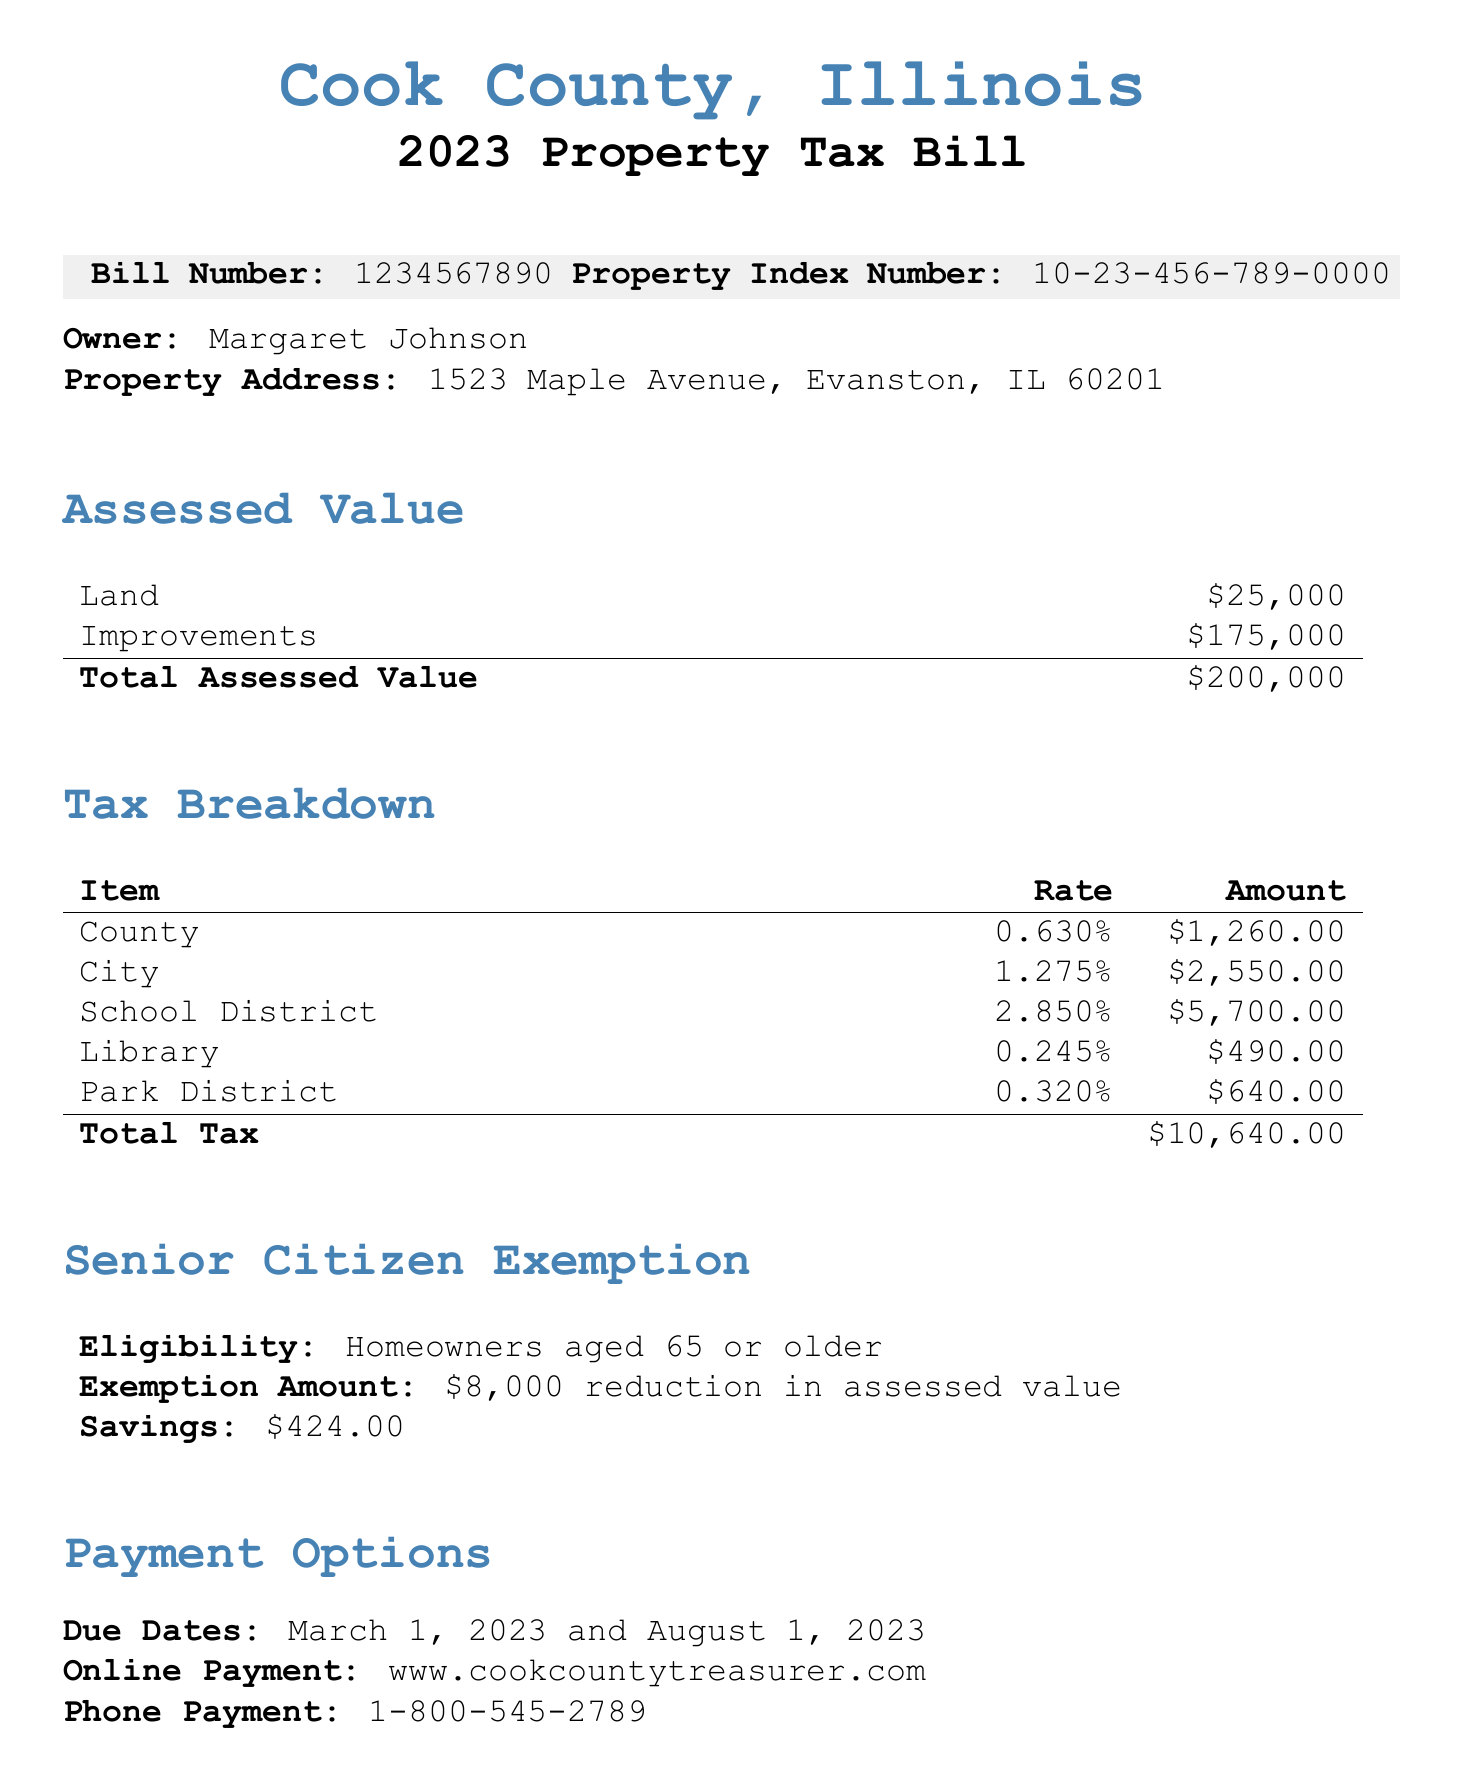What is the total assessed value? The total assessed value is provided in the breakdown of assessments in the document, which adds the land and improvements values.
Answer: $200,000 Who is the owner of the property? The owner's name is listed at the start of the bill.
Answer: Margaret Johnson What is the exemption amount for seniors? The exemption amount is specified under the senior citizen exemption section of the document.
Answer: $8,000 reduction in assessed value How much is the savings from the senior citizen exemption? The savings from the exemption is indicated in the same section, calculated based on the exemption amount.
Answer: $424.00 When is the first due date for payment? The due dates for payment are mentioned clearly in a dedicated section.
Answer: March 1, 2023 What is the total tax amount? The total tax is the sum of all the tax items listed in the tax breakdown section.
Answer: $10,640.00 What is the property index number? The property index number is provided at the top of the bill.
Answer: 10-23-456-789-0000 Where can I make an online payment? The online payment option includes a website address stated in the payment options section.
Answer: www.cookcountytreasurer.com What is the phone number for the Cook County Treasurer's Office? The document lists contact information, including phone numbers for relevant offices.
Answer: (312) 443-5100 